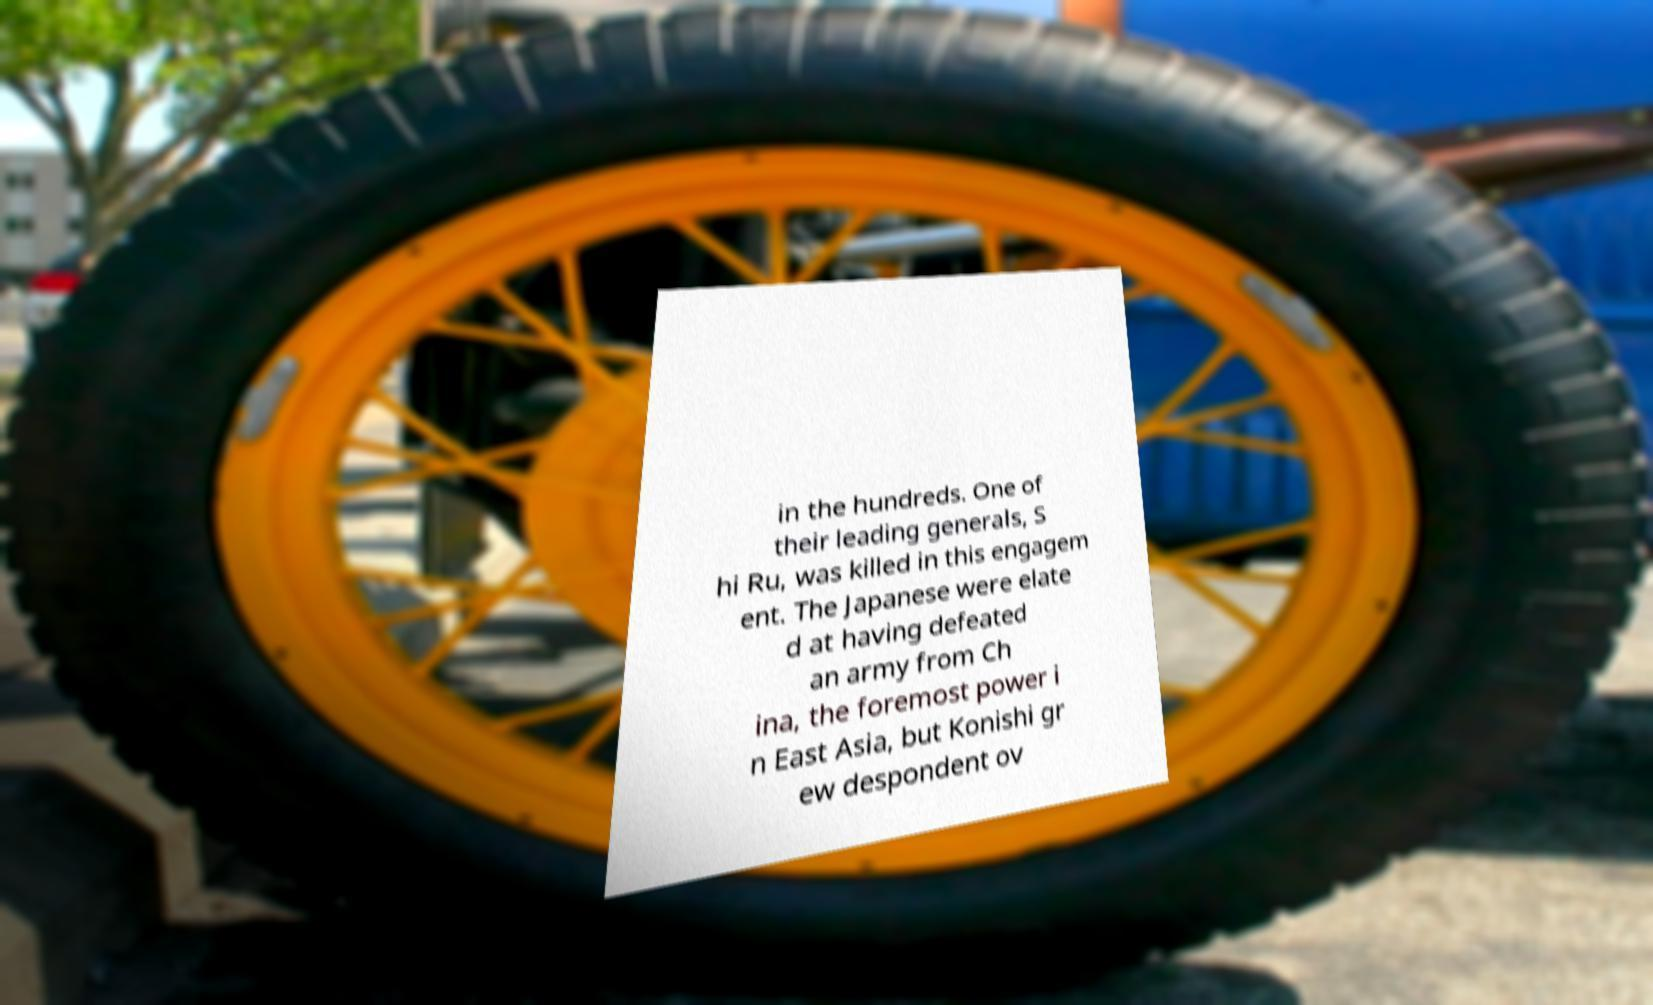Can you accurately transcribe the text from the provided image for me? in the hundreds. One of their leading generals, S hi Ru, was killed in this engagem ent. The Japanese were elate d at having defeated an army from Ch ina, the foremost power i n East Asia, but Konishi gr ew despondent ov 